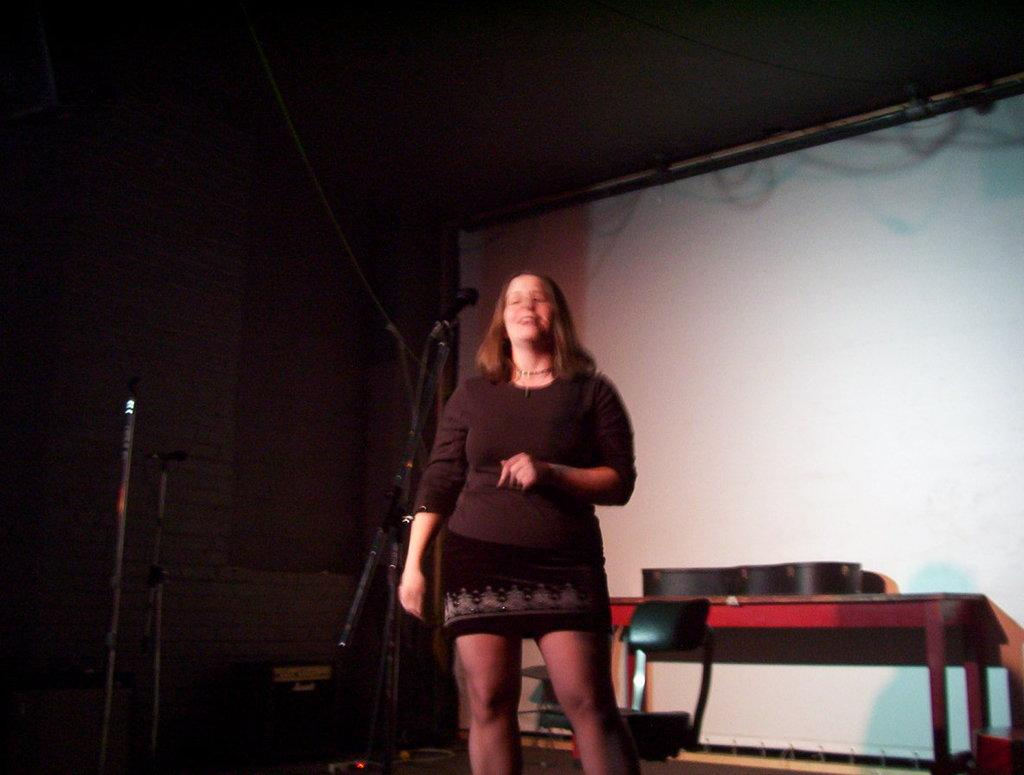Who is present in the image? There is a woman in the image. What is the woman doing in the image? The woman is smiling in the image. What is the woman standing in front of? The woman is standing in front of a mic. What can be seen in the background of the image? There is a chair, a table, and a wall in the background of the image. What type of collar is the woman wearing in the image? There is no collar visible in the image, as the woman is not wearing any clothing that would have a collar. 